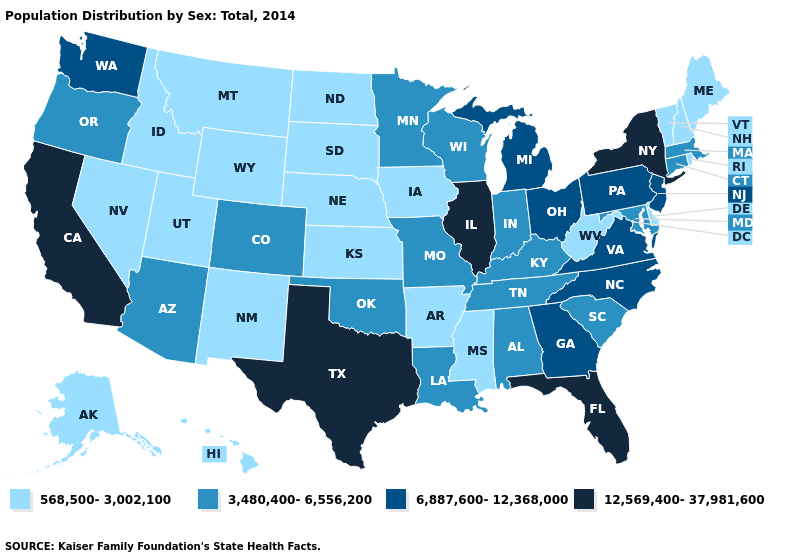Name the states that have a value in the range 6,887,600-12,368,000?
Short answer required. Georgia, Michigan, New Jersey, North Carolina, Ohio, Pennsylvania, Virginia, Washington. Among the states that border California , which have the highest value?
Give a very brief answer. Arizona, Oregon. Among the states that border Virginia , which have the highest value?
Quick response, please. North Carolina. Does Nevada have a higher value than Illinois?
Give a very brief answer. No. What is the value of Nevada?
Keep it brief. 568,500-3,002,100. Does West Virginia have a lower value than Mississippi?
Be succinct. No. Name the states that have a value in the range 568,500-3,002,100?
Keep it brief. Alaska, Arkansas, Delaware, Hawaii, Idaho, Iowa, Kansas, Maine, Mississippi, Montana, Nebraska, Nevada, New Hampshire, New Mexico, North Dakota, Rhode Island, South Dakota, Utah, Vermont, West Virginia, Wyoming. What is the value of North Dakota?
Concise answer only. 568,500-3,002,100. Which states have the highest value in the USA?
Be succinct. California, Florida, Illinois, New York, Texas. Does Texas have the highest value in the South?
Keep it brief. Yes. Among the states that border Wyoming , which have the lowest value?
Answer briefly. Idaho, Montana, Nebraska, South Dakota, Utah. Which states have the lowest value in the MidWest?
Short answer required. Iowa, Kansas, Nebraska, North Dakota, South Dakota. Name the states that have a value in the range 12,569,400-37,981,600?
Concise answer only. California, Florida, Illinois, New York, Texas. What is the highest value in the West ?
Concise answer only. 12,569,400-37,981,600. What is the value of Ohio?
Keep it brief. 6,887,600-12,368,000. 